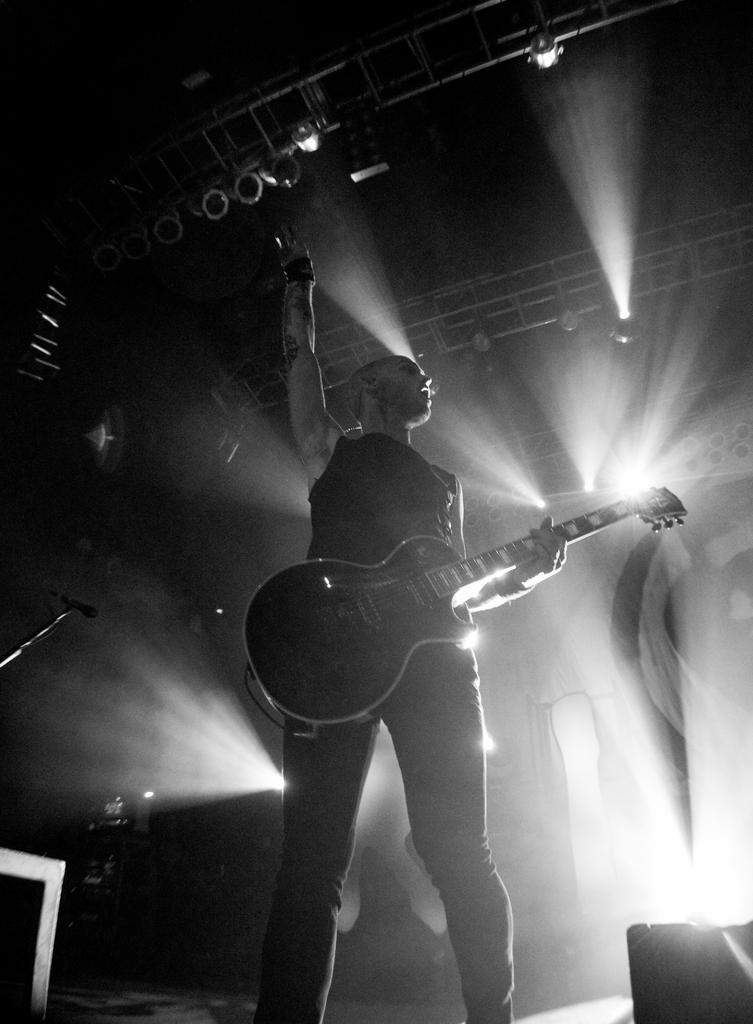How would you summarize this image in a sentence or two? In this picture,there is a man who is playing a guitar. There is a light on the roof. On the left side, there is a microphone. 